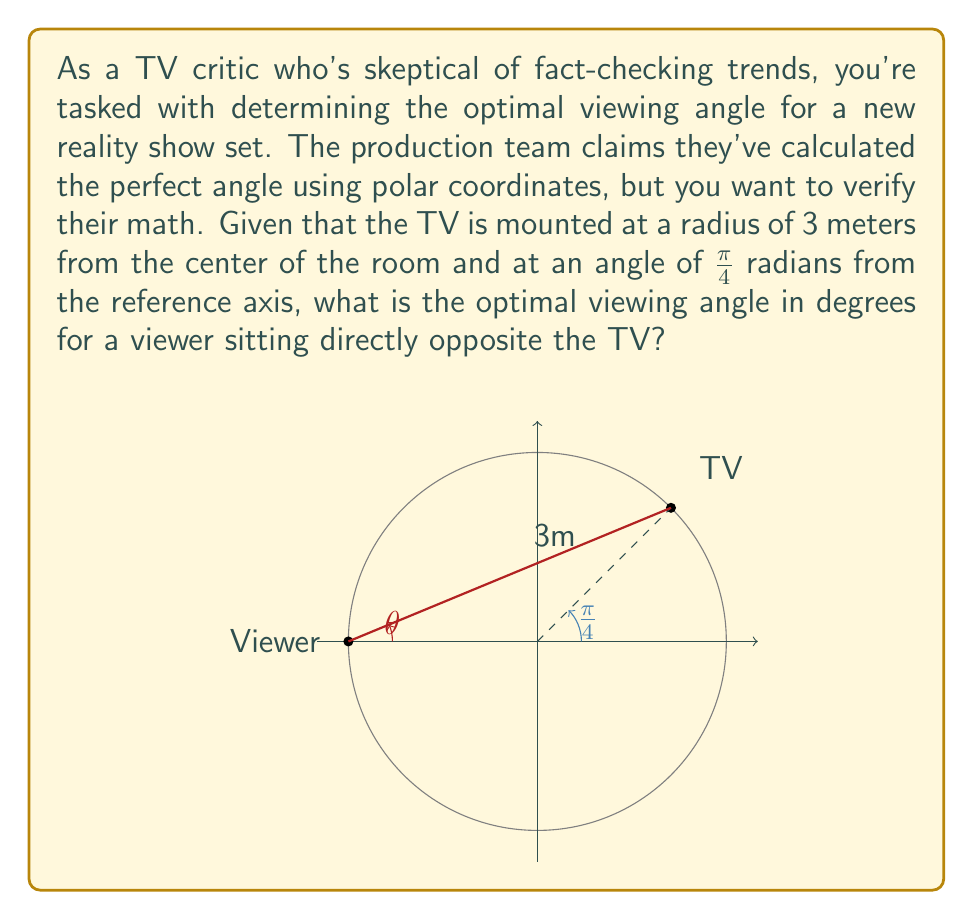Can you answer this question? Let's approach this step-by-step:

1) In polar coordinates, the TV's position is given by $(r, \theta) = (3, \frac{\pi}{4})$.

2) To convert this to Cartesian coordinates, we use:
   $x = r \cos(\theta) = 3 \cos(\frac{\pi}{4})$
   $y = r \sin(\theta) = 3 \sin(\frac{\pi}{4})$

3) The viewer is positioned at $(-3, 0)$ in Cartesian coordinates.

4) To find the optimal viewing angle, we need to calculate the angle between the line from the viewer to the TV and the positive x-axis.

5) We can use the arctangent function (atan2) to find this angle:

   $\theta = \arctan2(y_{TV} - y_{viewer}, x_{TV} - x_{viewer})$

6) Substituting the values:

   $\theta = \arctan2(3\sin(\frac{\pi}{4}) - 0, 3\cos(\frac{\pi}{4}) - (-3))$

7) Simplify:

   $\theta = \arctan2(3\sin(\frac{\pi}{4}), 3\cos(\frac{\pi}{4}) + 3)$

8) We know that $\sin(\frac{\pi}{4}) = \cos(\frac{\pi}{4}) = \frac{\sqrt{2}}{2}$

   $\theta = \arctan2(3\frac{\sqrt{2}}{2}, 3\frac{\sqrt{2}}{2} + 3)$

9) Simplify further:

   $\theta = \arctan2(3\sqrt{2}, 3\sqrt{2} + 6)$

10) Calculate this value and convert to degrees:

    $\theta \approx 0.3805 \text{ radians} \approx 21.80°$
Answer: $21.80°$ 